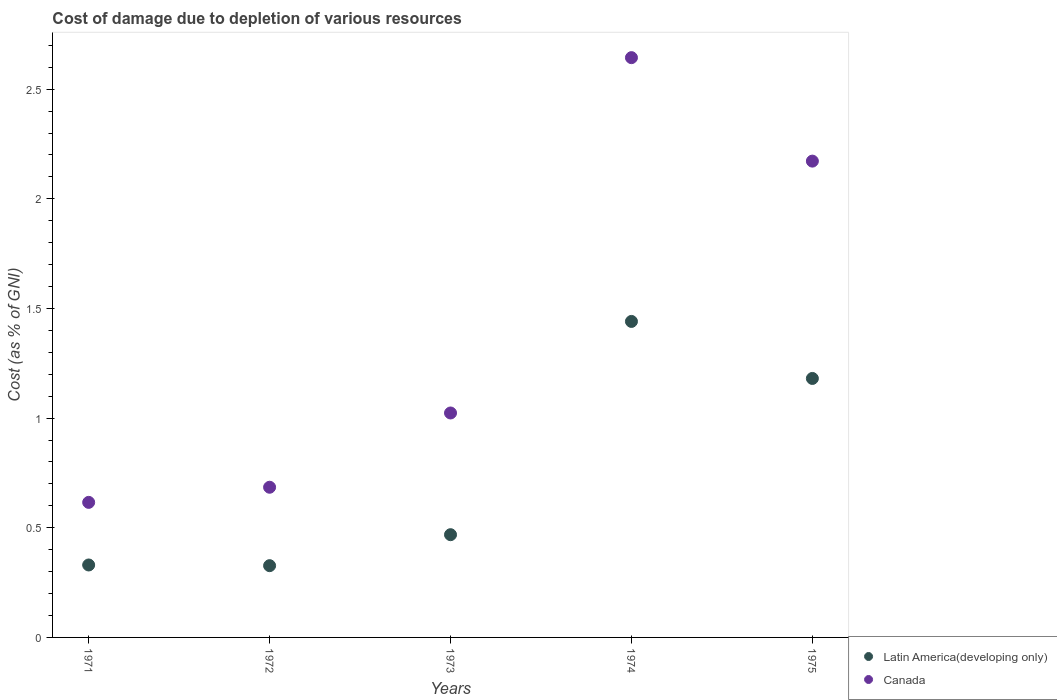Is the number of dotlines equal to the number of legend labels?
Offer a terse response. Yes. What is the cost of damage caused due to the depletion of various resources in Canada in 1975?
Provide a short and direct response. 2.17. Across all years, what is the maximum cost of damage caused due to the depletion of various resources in Latin America(developing only)?
Provide a short and direct response. 1.44. Across all years, what is the minimum cost of damage caused due to the depletion of various resources in Latin America(developing only)?
Make the answer very short. 0.33. In which year was the cost of damage caused due to the depletion of various resources in Canada maximum?
Offer a terse response. 1974. In which year was the cost of damage caused due to the depletion of various resources in Latin America(developing only) minimum?
Make the answer very short. 1972. What is the total cost of damage caused due to the depletion of various resources in Latin America(developing only) in the graph?
Your answer should be very brief. 3.75. What is the difference between the cost of damage caused due to the depletion of various resources in Latin America(developing only) in 1971 and that in 1973?
Your answer should be compact. -0.14. What is the difference between the cost of damage caused due to the depletion of various resources in Latin America(developing only) in 1973 and the cost of damage caused due to the depletion of various resources in Canada in 1972?
Make the answer very short. -0.22. What is the average cost of damage caused due to the depletion of various resources in Latin America(developing only) per year?
Provide a succinct answer. 0.75. In the year 1974, what is the difference between the cost of damage caused due to the depletion of various resources in Canada and cost of damage caused due to the depletion of various resources in Latin America(developing only)?
Ensure brevity in your answer.  1.2. In how many years, is the cost of damage caused due to the depletion of various resources in Canada greater than 2.2 %?
Give a very brief answer. 1. What is the ratio of the cost of damage caused due to the depletion of various resources in Canada in 1971 to that in 1973?
Offer a very short reply. 0.6. Is the cost of damage caused due to the depletion of various resources in Canada in 1972 less than that in 1973?
Provide a succinct answer. Yes. Is the difference between the cost of damage caused due to the depletion of various resources in Canada in 1971 and 1973 greater than the difference between the cost of damage caused due to the depletion of various resources in Latin America(developing only) in 1971 and 1973?
Offer a very short reply. No. What is the difference between the highest and the second highest cost of damage caused due to the depletion of various resources in Latin America(developing only)?
Give a very brief answer. 0.26. What is the difference between the highest and the lowest cost of damage caused due to the depletion of various resources in Canada?
Make the answer very short. 2.03. How many years are there in the graph?
Offer a terse response. 5. Does the graph contain any zero values?
Your answer should be very brief. No. How many legend labels are there?
Provide a short and direct response. 2. How are the legend labels stacked?
Your response must be concise. Vertical. What is the title of the graph?
Offer a very short reply. Cost of damage due to depletion of various resources. What is the label or title of the Y-axis?
Make the answer very short. Cost (as % of GNI). What is the Cost (as % of GNI) in Latin America(developing only) in 1971?
Provide a short and direct response. 0.33. What is the Cost (as % of GNI) in Canada in 1971?
Give a very brief answer. 0.62. What is the Cost (as % of GNI) in Latin America(developing only) in 1972?
Your answer should be compact. 0.33. What is the Cost (as % of GNI) of Canada in 1972?
Your answer should be very brief. 0.68. What is the Cost (as % of GNI) in Latin America(developing only) in 1973?
Offer a very short reply. 0.47. What is the Cost (as % of GNI) in Canada in 1973?
Keep it short and to the point. 1.02. What is the Cost (as % of GNI) in Latin America(developing only) in 1974?
Offer a terse response. 1.44. What is the Cost (as % of GNI) of Canada in 1974?
Offer a very short reply. 2.64. What is the Cost (as % of GNI) of Latin America(developing only) in 1975?
Ensure brevity in your answer.  1.18. What is the Cost (as % of GNI) of Canada in 1975?
Your answer should be very brief. 2.17. Across all years, what is the maximum Cost (as % of GNI) in Latin America(developing only)?
Your answer should be very brief. 1.44. Across all years, what is the maximum Cost (as % of GNI) in Canada?
Give a very brief answer. 2.64. Across all years, what is the minimum Cost (as % of GNI) in Latin America(developing only)?
Offer a very short reply. 0.33. Across all years, what is the minimum Cost (as % of GNI) in Canada?
Your answer should be compact. 0.62. What is the total Cost (as % of GNI) of Latin America(developing only) in the graph?
Offer a very short reply. 3.75. What is the total Cost (as % of GNI) of Canada in the graph?
Keep it short and to the point. 7.14. What is the difference between the Cost (as % of GNI) of Latin America(developing only) in 1971 and that in 1972?
Provide a succinct answer. 0. What is the difference between the Cost (as % of GNI) of Canada in 1971 and that in 1972?
Your answer should be compact. -0.07. What is the difference between the Cost (as % of GNI) of Latin America(developing only) in 1971 and that in 1973?
Ensure brevity in your answer.  -0.14. What is the difference between the Cost (as % of GNI) of Canada in 1971 and that in 1973?
Your response must be concise. -0.41. What is the difference between the Cost (as % of GNI) of Latin America(developing only) in 1971 and that in 1974?
Offer a very short reply. -1.11. What is the difference between the Cost (as % of GNI) of Canada in 1971 and that in 1974?
Your response must be concise. -2.03. What is the difference between the Cost (as % of GNI) in Latin America(developing only) in 1971 and that in 1975?
Your answer should be very brief. -0.85. What is the difference between the Cost (as % of GNI) of Canada in 1971 and that in 1975?
Your answer should be compact. -1.56. What is the difference between the Cost (as % of GNI) in Latin America(developing only) in 1972 and that in 1973?
Give a very brief answer. -0.14. What is the difference between the Cost (as % of GNI) in Canada in 1972 and that in 1973?
Ensure brevity in your answer.  -0.34. What is the difference between the Cost (as % of GNI) in Latin America(developing only) in 1972 and that in 1974?
Ensure brevity in your answer.  -1.11. What is the difference between the Cost (as % of GNI) of Canada in 1972 and that in 1974?
Provide a succinct answer. -1.96. What is the difference between the Cost (as % of GNI) in Latin America(developing only) in 1972 and that in 1975?
Keep it short and to the point. -0.85. What is the difference between the Cost (as % of GNI) in Canada in 1972 and that in 1975?
Give a very brief answer. -1.49. What is the difference between the Cost (as % of GNI) in Latin America(developing only) in 1973 and that in 1974?
Your answer should be very brief. -0.97. What is the difference between the Cost (as % of GNI) of Canada in 1973 and that in 1974?
Offer a terse response. -1.62. What is the difference between the Cost (as % of GNI) in Latin America(developing only) in 1973 and that in 1975?
Keep it short and to the point. -0.71. What is the difference between the Cost (as % of GNI) in Canada in 1973 and that in 1975?
Make the answer very short. -1.15. What is the difference between the Cost (as % of GNI) in Latin America(developing only) in 1974 and that in 1975?
Provide a short and direct response. 0.26. What is the difference between the Cost (as % of GNI) in Canada in 1974 and that in 1975?
Give a very brief answer. 0.47. What is the difference between the Cost (as % of GNI) of Latin America(developing only) in 1971 and the Cost (as % of GNI) of Canada in 1972?
Offer a terse response. -0.35. What is the difference between the Cost (as % of GNI) of Latin America(developing only) in 1971 and the Cost (as % of GNI) of Canada in 1973?
Offer a very short reply. -0.69. What is the difference between the Cost (as % of GNI) in Latin America(developing only) in 1971 and the Cost (as % of GNI) in Canada in 1974?
Give a very brief answer. -2.31. What is the difference between the Cost (as % of GNI) in Latin America(developing only) in 1971 and the Cost (as % of GNI) in Canada in 1975?
Keep it short and to the point. -1.84. What is the difference between the Cost (as % of GNI) of Latin America(developing only) in 1972 and the Cost (as % of GNI) of Canada in 1973?
Your response must be concise. -0.7. What is the difference between the Cost (as % of GNI) in Latin America(developing only) in 1972 and the Cost (as % of GNI) in Canada in 1974?
Your answer should be compact. -2.32. What is the difference between the Cost (as % of GNI) in Latin America(developing only) in 1972 and the Cost (as % of GNI) in Canada in 1975?
Keep it short and to the point. -1.84. What is the difference between the Cost (as % of GNI) of Latin America(developing only) in 1973 and the Cost (as % of GNI) of Canada in 1974?
Offer a terse response. -2.18. What is the difference between the Cost (as % of GNI) in Latin America(developing only) in 1973 and the Cost (as % of GNI) in Canada in 1975?
Make the answer very short. -1.7. What is the difference between the Cost (as % of GNI) of Latin America(developing only) in 1974 and the Cost (as % of GNI) of Canada in 1975?
Your response must be concise. -0.73. What is the average Cost (as % of GNI) of Latin America(developing only) per year?
Your response must be concise. 0.75. What is the average Cost (as % of GNI) in Canada per year?
Make the answer very short. 1.43. In the year 1971, what is the difference between the Cost (as % of GNI) in Latin America(developing only) and Cost (as % of GNI) in Canada?
Ensure brevity in your answer.  -0.29. In the year 1972, what is the difference between the Cost (as % of GNI) in Latin America(developing only) and Cost (as % of GNI) in Canada?
Ensure brevity in your answer.  -0.36. In the year 1973, what is the difference between the Cost (as % of GNI) of Latin America(developing only) and Cost (as % of GNI) of Canada?
Provide a succinct answer. -0.56. In the year 1974, what is the difference between the Cost (as % of GNI) in Latin America(developing only) and Cost (as % of GNI) in Canada?
Provide a short and direct response. -1.2. In the year 1975, what is the difference between the Cost (as % of GNI) in Latin America(developing only) and Cost (as % of GNI) in Canada?
Keep it short and to the point. -0.99. What is the ratio of the Cost (as % of GNI) in Latin America(developing only) in 1971 to that in 1972?
Offer a very short reply. 1.01. What is the ratio of the Cost (as % of GNI) of Canada in 1971 to that in 1972?
Your answer should be compact. 0.9. What is the ratio of the Cost (as % of GNI) in Latin America(developing only) in 1971 to that in 1973?
Provide a short and direct response. 0.71. What is the ratio of the Cost (as % of GNI) of Canada in 1971 to that in 1973?
Make the answer very short. 0.6. What is the ratio of the Cost (as % of GNI) of Latin America(developing only) in 1971 to that in 1974?
Make the answer very short. 0.23. What is the ratio of the Cost (as % of GNI) in Canada in 1971 to that in 1974?
Keep it short and to the point. 0.23. What is the ratio of the Cost (as % of GNI) of Latin America(developing only) in 1971 to that in 1975?
Make the answer very short. 0.28. What is the ratio of the Cost (as % of GNI) in Canada in 1971 to that in 1975?
Ensure brevity in your answer.  0.28. What is the ratio of the Cost (as % of GNI) in Latin America(developing only) in 1972 to that in 1973?
Keep it short and to the point. 0.7. What is the ratio of the Cost (as % of GNI) in Canada in 1972 to that in 1973?
Make the answer very short. 0.67. What is the ratio of the Cost (as % of GNI) in Latin America(developing only) in 1972 to that in 1974?
Make the answer very short. 0.23. What is the ratio of the Cost (as % of GNI) in Canada in 1972 to that in 1974?
Keep it short and to the point. 0.26. What is the ratio of the Cost (as % of GNI) of Latin America(developing only) in 1972 to that in 1975?
Provide a short and direct response. 0.28. What is the ratio of the Cost (as % of GNI) in Canada in 1972 to that in 1975?
Provide a succinct answer. 0.32. What is the ratio of the Cost (as % of GNI) of Latin America(developing only) in 1973 to that in 1974?
Offer a terse response. 0.33. What is the ratio of the Cost (as % of GNI) in Canada in 1973 to that in 1974?
Offer a terse response. 0.39. What is the ratio of the Cost (as % of GNI) in Latin America(developing only) in 1973 to that in 1975?
Your answer should be compact. 0.4. What is the ratio of the Cost (as % of GNI) of Canada in 1973 to that in 1975?
Give a very brief answer. 0.47. What is the ratio of the Cost (as % of GNI) of Latin America(developing only) in 1974 to that in 1975?
Your response must be concise. 1.22. What is the ratio of the Cost (as % of GNI) of Canada in 1974 to that in 1975?
Offer a terse response. 1.22. What is the difference between the highest and the second highest Cost (as % of GNI) in Latin America(developing only)?
Keep it short and to the point. 0.26. What is the difference between the highest and the second highest Cost (as % of GNI) in Canada?
Provide a succinct answer. 0.47. What is the difference between the highest and the lowest Cost (as % of GNI) of Latin America(developing only)?
Your answer should be compact. 1.11. What is the difference between the highest and the lowest Cost (as % of GNI) in Canada?
Provide a short and direct response. 2.03. 